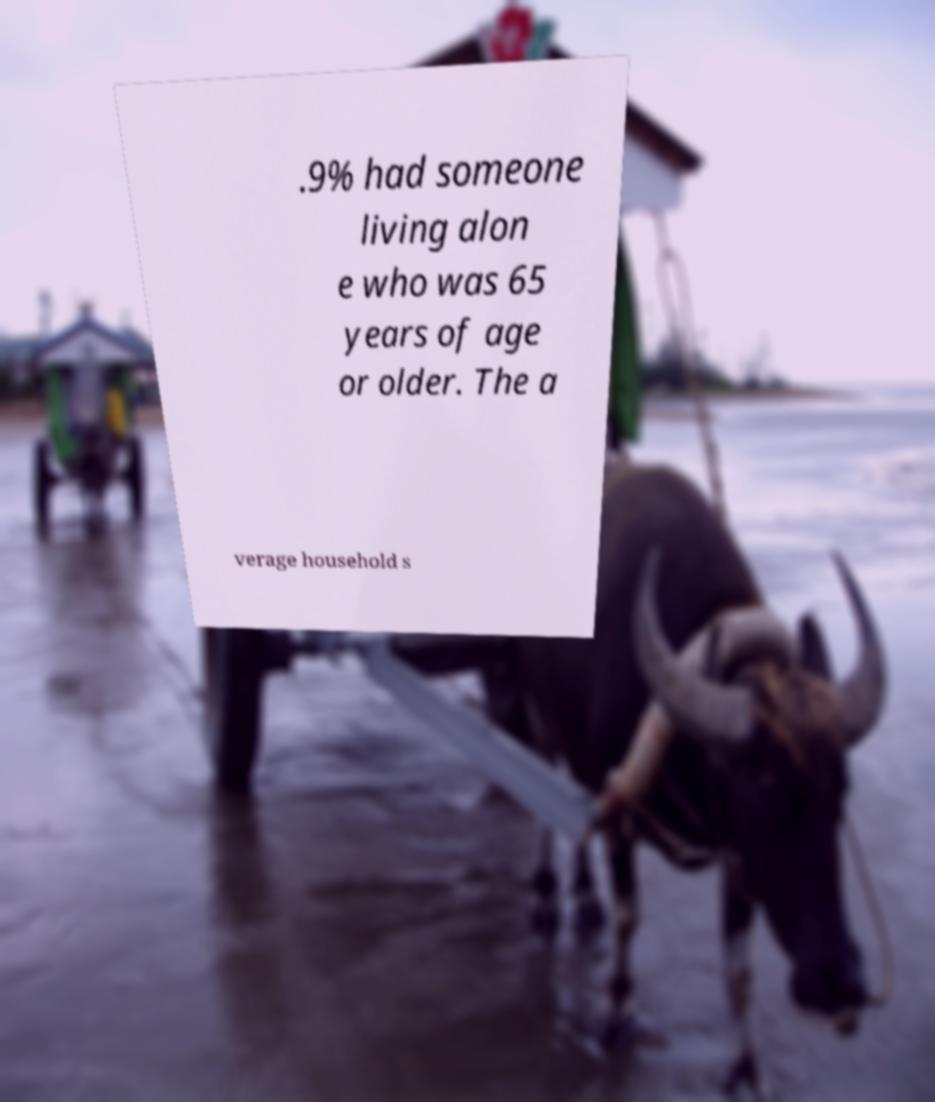Could you extract and type out the text from this image? .9% had someone living alon e who was 65 years of age or older. The a verage household s 